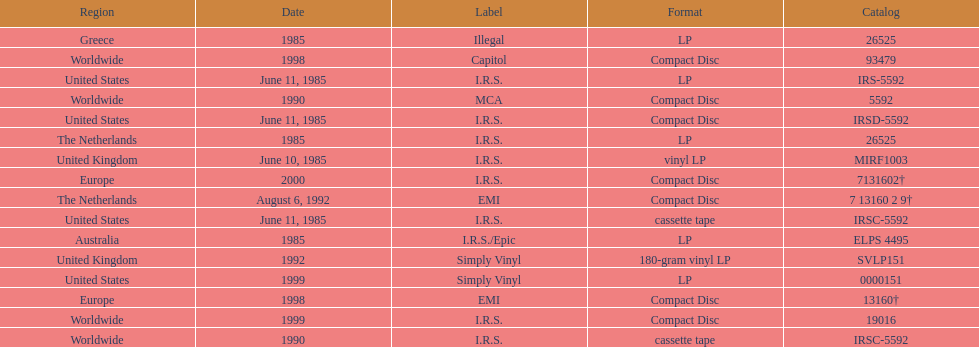Which is the only region with vinyl lp format? United Kingdom. 